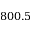Convert formula to latex. <formula><loc_0><loc_0><loc_500><loc_500>8 0 0 . 5</formula> 